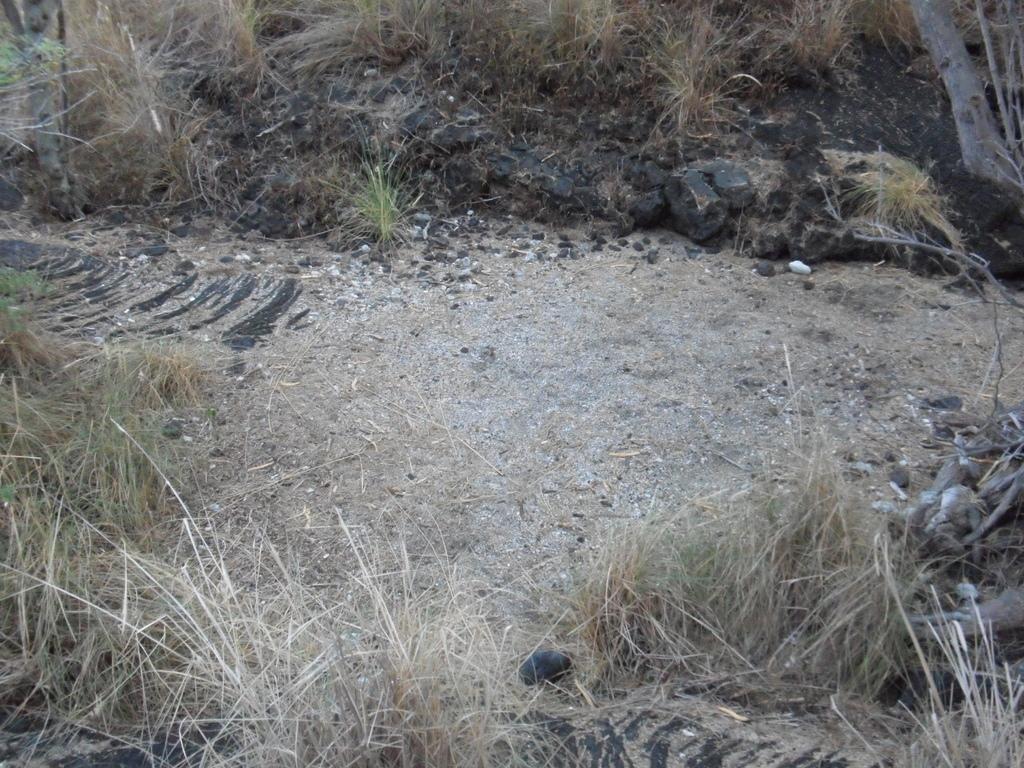How would you summarize this image in a sentence or two? In this image we can see a land with dried grass, stones and the bark of a tree. 